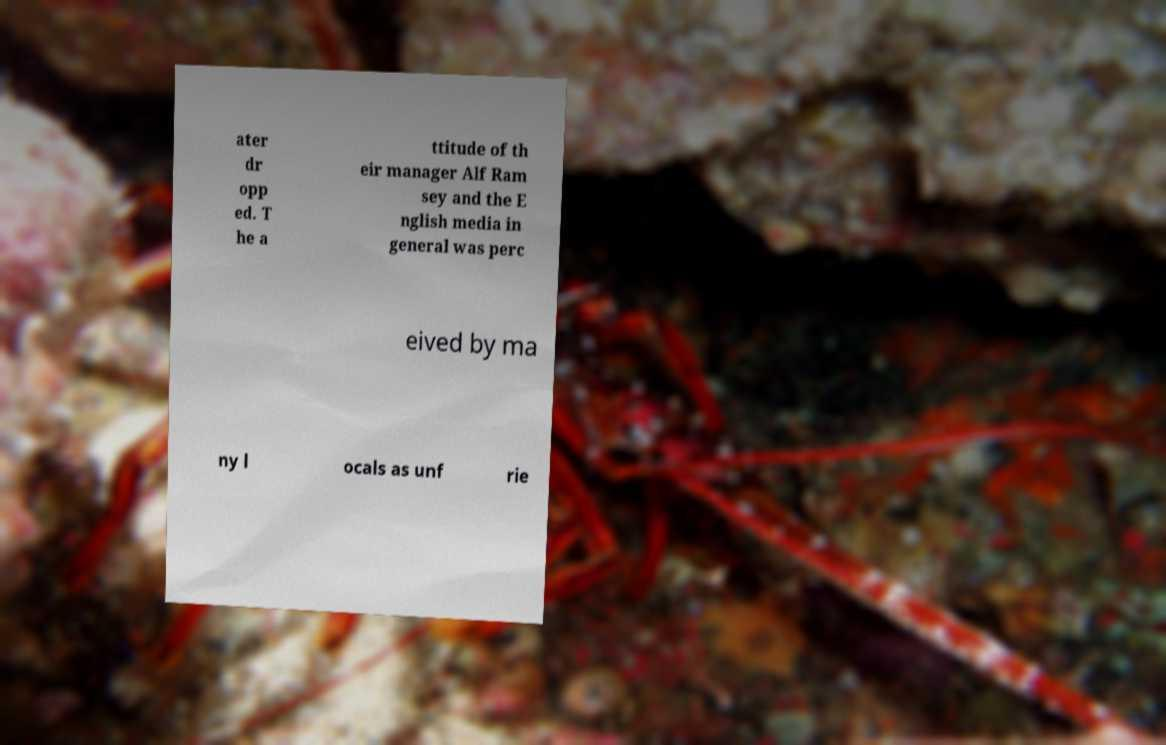There's text embedded in this image that I need extracted. Can you transcribe it verbatim? ater dr opp ed. T he a ttitude of th eir manager Alf Ram sey and the E nglish media in general was perc eived by ma ny l ocals as unf rie 